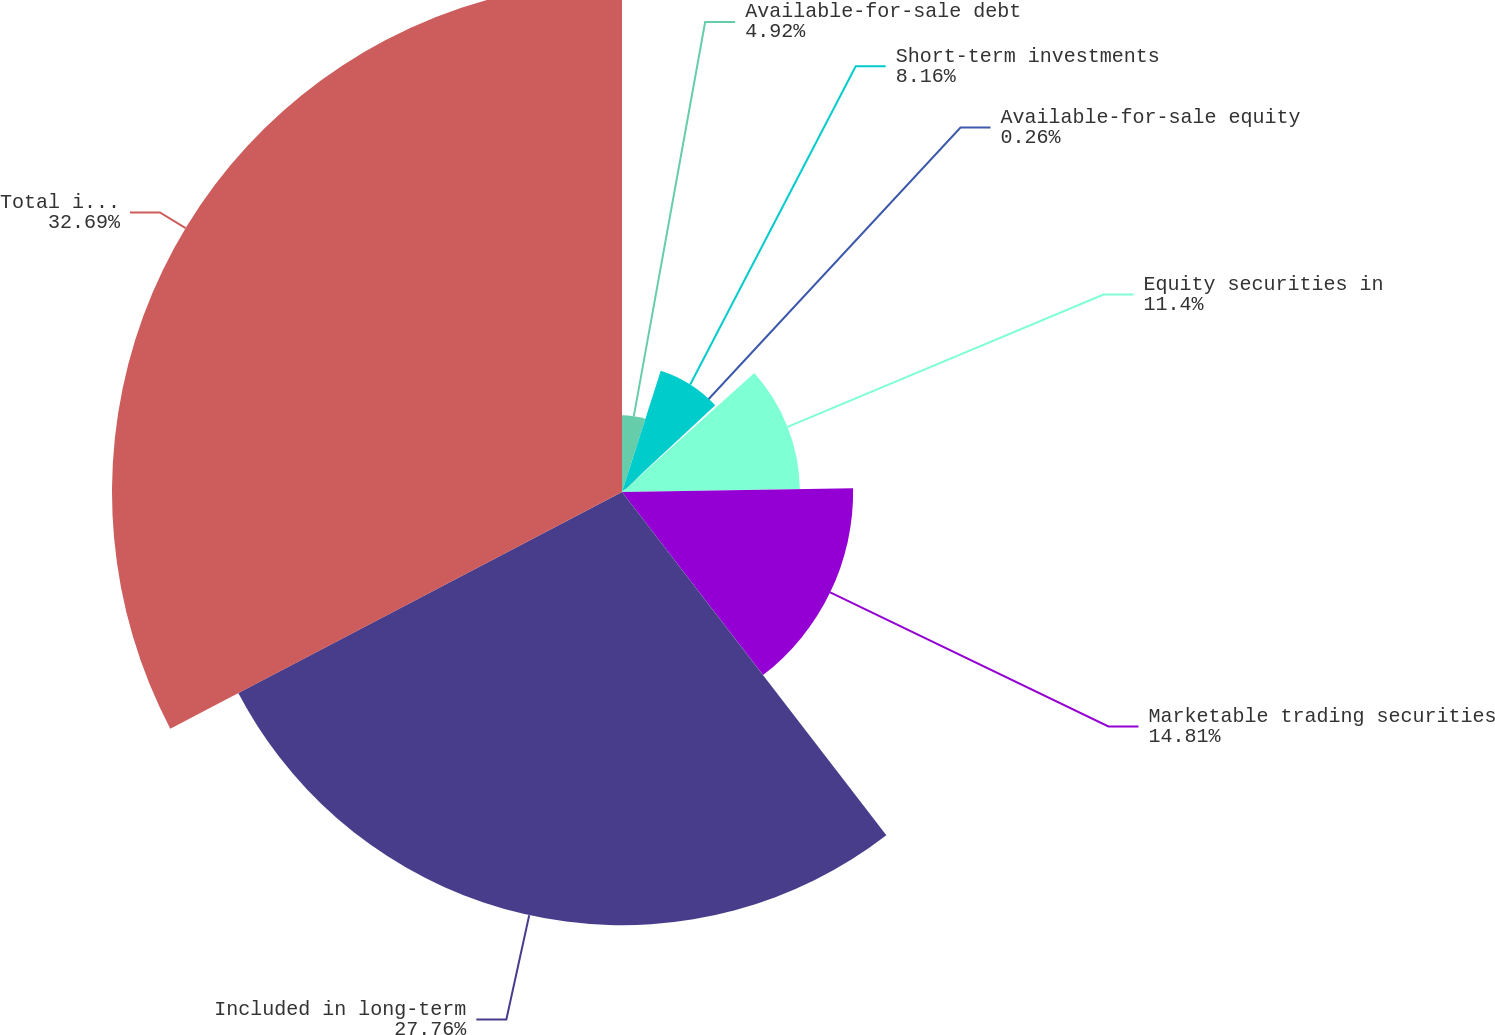Convert chart. <chart><loc_0><loc_0><loc_500><loc_500><pie_chart><fcel>Available-for-sale debt<fcel>Short-term investments<fcel>Available-for-sale equity<fcel>Equity securities in<fcel>Marketable trading securities<fcel>Included in long-term<fcel>Total investments<nl><fcel>4.92%<fcel>8.16%<fcel>0.26%<fcel>11.4%<fcel>14.81%<fcel>27.76%<fcel>32.68%<nl></chart> 